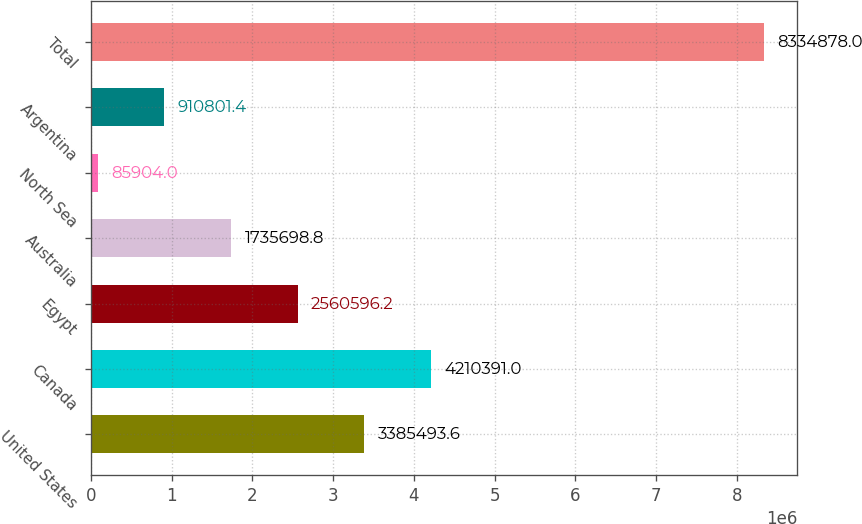Convert chart. <chart><loc_0><loc_0><loc_500><loc_500><bar_chart><fcel>United States<fcel>Canada<fcel>Egypt<fcel>Australia<fcel>North Sea<fcel>Argentina<fcel>Total<nl><fcel>3.38549e+06<fcel>4.21039e+06<fcel>2.5606e+06<fcel>1.7357e+06<fcel>85904<fcel>910801<fcel>8.33488e+06<nl></chart> 